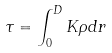Convert formula to latex. <formula><loc_0><loc_0><loc_500><loc_500>\tau = \int _ { 0 } ^ { D } K \rho d r</formula> 